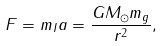<formula> <loc_0><loc_0><loc_500><loc_500>F = m _ { I } a = \frac { G M _ { \odot } m _ { g } } { r ^ { 2 } } ,</formula> 